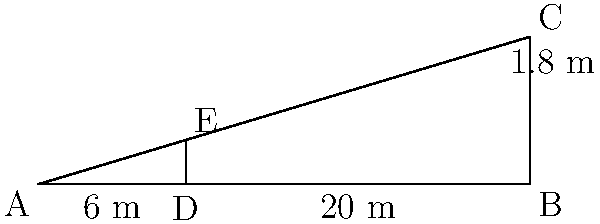While on a photography expedition in a remote mountain range, you want to estimate the height of a distant peak. You set up your camera on a tripod 6 meters tall and align it with the mountain's peak. You then walk 20 meters away from the tripod and find that the top of the tripod aligns with the mountain's peak when viewed from a height of 1.8 meters (your eye level). Using the principle of similar triangles, estimate the height of the mountain. Let's approach this step-by-step:

1) We can form two similar triangles: 
   - Triangle ADE (smaller triangle)
   - Triangle ABC (larger triangle)

2) In triangle ADE:
   - AD = 6 m (tripod height)
   - DE = 1.8 m (your eye level)
   - AE = 6 + 1.8 = 7.8 m (total height of smaller triangle)

3) For the base of the triangles:
   - Base of smaller triangle (AD to your position) = 20 m
   - Base of larger triangle (AB) = 20 + x, where x is the distance from the tripod to the mountain

4) Using the principle of similar triangles:
   $$\frac{AE}{AC} = \frac{AD}{AB}$$

5) Substituting known values:
   $$\frac{7.8}{y} = \frac{20}{20+x}$$
   where y is the height of the mountain

6) Cross multiply:
   $$7.8(20+x) = 20y$$

7) We don't know x, but we can eliminate it by using the same ratio for the smaller triangle:
   $$\frac{1.8}{6} = \frac{20}{20+x}$$

8) Solving this:
   $$1.8(20+x) = 120$$
   $$36 + 1.8x = 120$$
   $$1.8x = 84$$
   $$x = 46.67$$

9) Substituting this back into the equation from step 6:
   $$7.8(20+46.67) = 20y$$
   $$7.8(66.67) = 20y$$
   $$520 = 20y$$
   $$y = 26$$

Therefore, the estimated height of the mountain is 26 meters.
Answer: 26 meters 